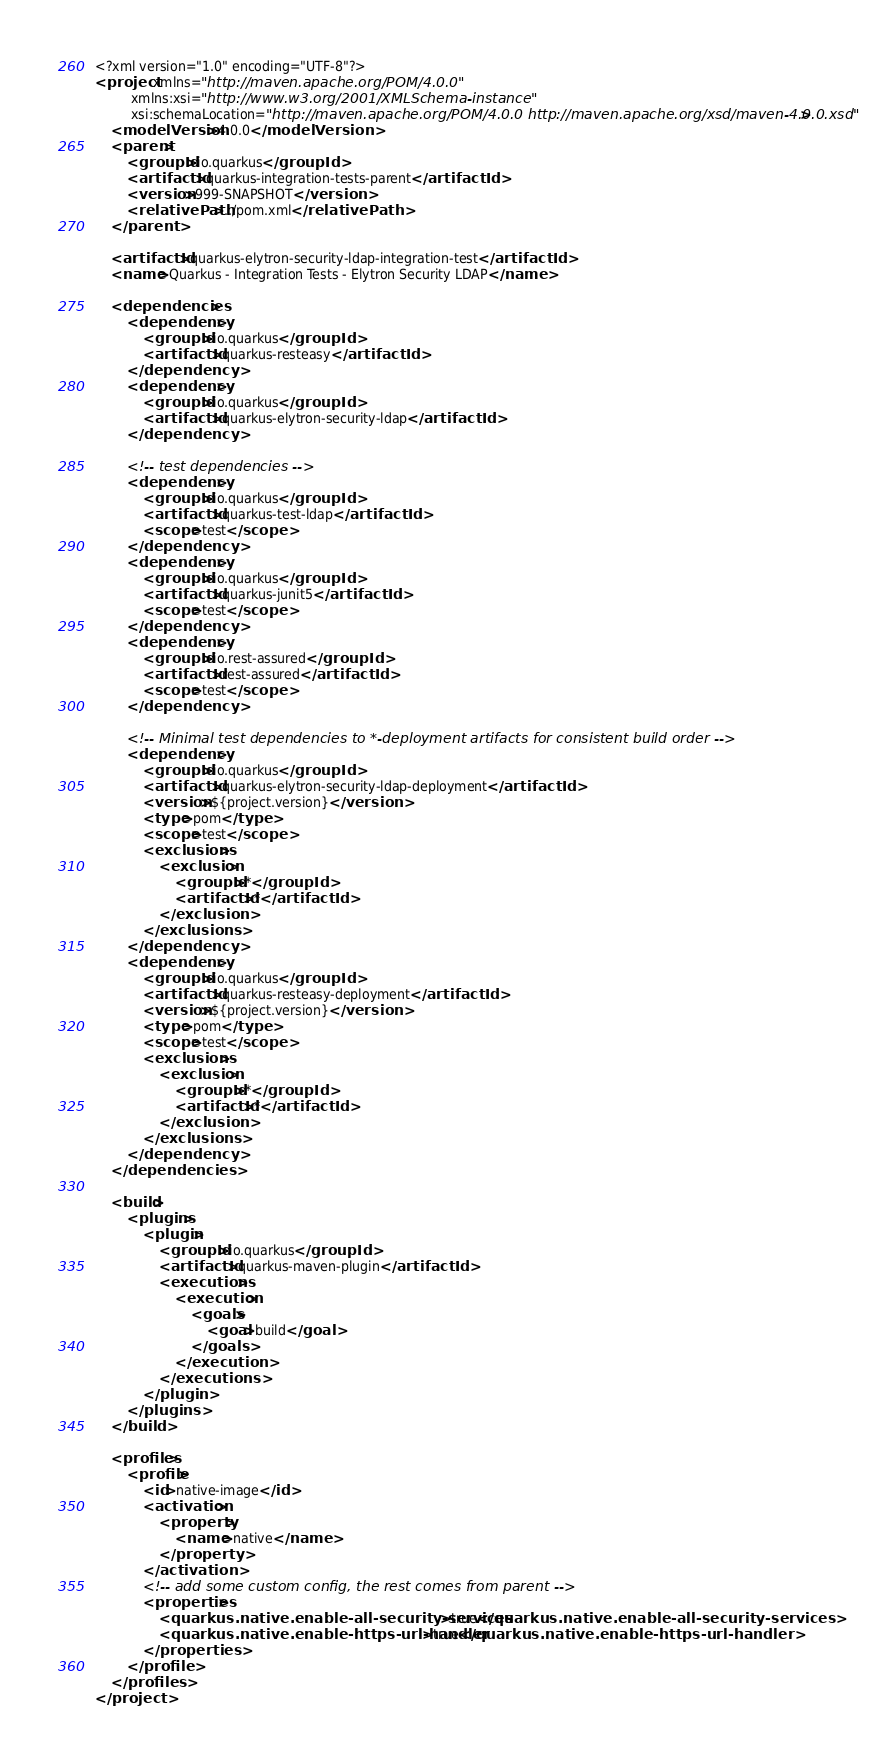<code> <loc_0><loc_0><loc_500><loc_500><_XML_><?xml version="1.0" encoding="UTF-8"?>
<project xmlns="http://maven.apache.org/POM/4.0.0"
         xmlns:xsi="http://www.w3.org/2001/XMLSchema-instance"
         xsi:schemaLocation="http://maven.apache.org/POM/4.0.0 http://maven.apache.org/xsd/maven-4.0.0.xsd">
    <modelVersion>4.0.0</modelVersion>
    <parent>
        <groupId>io.quarkus</groupId>
        <artifactId>quarkus-integration-tests-parent</artifactId>
        <version>999-SNAPSHOT</version>
        <relativePath>../pom.xml</relativePath>
    </parent>

    <artifactId>quarkus-elytron-security-ldap-integration-test</artifactId>
    <name>Quarkus - Integration Tests - Elytron Security LDAP</name>

    <dependencies>
        <dependency>
            <groupId>io.quarkus</groupId>
            <artifactId>quarkus-resteasy</artifactId>
        </dependency>
        <dependency>
            <groupId>io.quarkus</groupId>
            <artifactId>quarkus-elytron-security-ldap</artifactId>
        </dependency>

        <!-- test dependencies -->
        <dependency>
            <groupId>io.quarkus</groupId>
            <artifactId>quarkus-test-ldap</artifactId>
            <scope>test</scope>
        </dependency>
        <dependency>
            <groupId>io.quarkus</groupId>
            <artifactId>quarkus-junit5</artifactId>
            <scope>test</scope>
        </dependency>
        <dependency>
            <groupId>io.rest-assured</groupId>
            <artifactId>rest-assured</artifactId>
            <scope>test</scope>
        </dependency>

        <!-- Minimal test dependencies to *-deployment artifacts for consistent build order -->
        <dependency>
            <groupId>io.quarkus</groupId>
            <artifactId>quarkus-elytron-security-ldap-deployment</artifactId>
            <version>${project.version}</version>
            <type>pom</type>
            <scope>test</scope>
            <exclusions>
                <exclusion>
                    <groupId>*</groupId>
                    <artifactId>*</artifactId>
                </exclusion>
            </exclusions>
        </dependency>
        <dependency>
            <groupId>io.quarkus</groupId>
            <artifactId>quarkus-resteasy-deployment</artifactId>
            <version>${project.version}</version>
            <type>pom</type>
            <scope>test</scope>
            <exclusions>
                <exclusion>
                    <groupId>*</groupId>
                    <artifactId>*</artifactId>
                </exclusion>
            </exclusions>
        </dependency>
    </dependencies>

    <build>
        <plugins>
            <plugin>
                <groupId>io.quarkus</groupId>
                <artifactId>quarkus-maven-plugin</artifactId>
                <executions>
                    <execution>
                        <goals>
                            <goal>build</goal>
                        </goals>
                    </execution>
                </executions>
            </plugin>
        </plugins>
    </build>

    <profiles>
        <profile>
            <id>native-image</id>
            <activation>
                <property>
                    <name>native</name>
                </property>
            </activation>
            <!-- add some custom config, the rest comes from parent -->
            <properties>
                <quarkus.native.enable-all-security-services>true</quarkus.native.enable-all-security-services>
                <quarkus.native.enable-https-url-handler>true</quarkus.native.enable-https-url-handler>
            </properties>
        </profile>
    </profiles>
</project>
</code> 